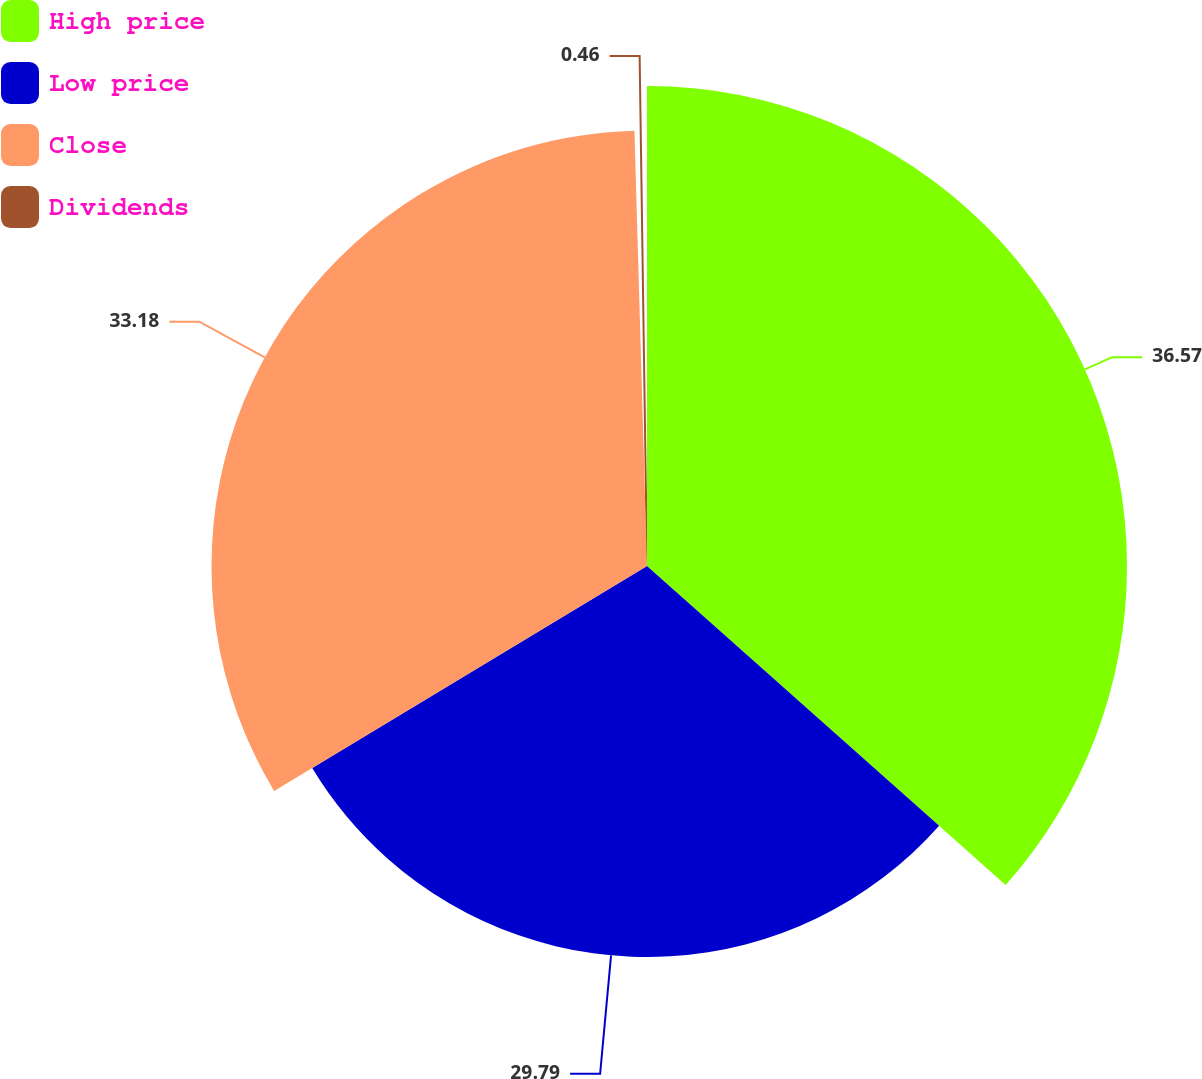Convert chart to OTSL. <chart><loc_0><loc_0><loc_500><loc_500><pie_chart><fcel>High price<fcel>Low price<fcel>Close<fcel>Dividends<nl><fcel>36.57%<fcel>29.79%<fcel>33.18%<fcel>0.46%<nl></chart> 